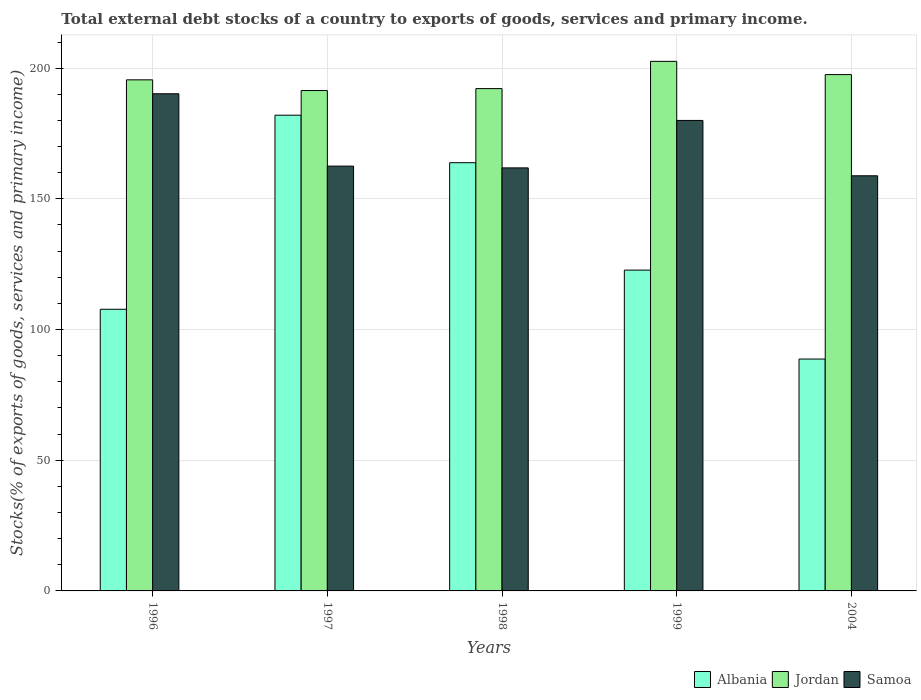How many different coloured bars are there?
Provide a succinct answer. 3. How many groups of bars are there?
Your response must be concise. 5. Are the number of bars per tick equal to the number of legend labels?
Offer a terse response. Yes. How many bars are there on the 4th tick from the right?
Offer a terse response. 3. What is the label of the 5th group of bars from the left?
Offer a terse response. 2004. What is the total debt stocks in Jordan in 2004?
Make the answer very short. 197.54. Across all years, what is the maximum total debt stocks in Jordan?
Make the answer very short. 202.6. Across all years, what is the minimum total debt stocks in Jordan?
Offer a very short reply. 191.43. In which year was the total debt stocks in Albania maximum?
Keep it short and to the point. 1997. What is the total total debt stocks in Albania in the graph?
Provide a short and direct response. 665.02. What is the difference between the total debt stocks in Albania in 1996 and that in 1997?
Give a very brief answer. -74.25. What is the difference between the total debt stocks in Samoa in 1997 and the total debt stocks in Albania in 2004?
Provide a short and direct response. 73.81. What is the average total debt stocks in Samoa per year?
Your answer should be very brief. 170.68. In the year 1996, what is the difference between the total debt stocks in Jordan and total debt stocks in Albania?
Offer a terse response. 87.78. What is the ratio of the total debt stocks in Jordan in 1996 to that in 1997?
Offer a terse response. 1.02. What is the difference between the highest and the second highest total debt stocks in Albania?
Make the answer very short. 18.17. What is the difference between the highest and the lowest total debt stocks in Albania?
Offer a very short reply. 93.29. What does the 3rd bar from the left in 2004 represents?
Your answer should be very brief. Samoa. What does the 3rd bar from the right in 1996 represents?
Ensure brevity in your answer.  Albania. How many bars are there?
Offer a terse response. 15. What is the difference between two consecutive major ticks on the Y-axis?
Your answer should be very brief. 50. Are the values on the major ticks of Y-axis written in scientific E-notation?
Offer a very short reply. No. Does the graph contain any zero values?
Keep it short and to the point. No. Does the graph contain grids?
Your response must be concise. Yes. What is the title of the graph?
Offer a terse response. Total external debt stocks of a country to exports of goods, services and primary income. What is the label or title of the X-axis?
Offer a terse response. Years. What is the label or title of the Y-axis?
Provide a short and direct response. Stocks(% of exports of goods, services and primary income). What is the Stocks(% of exports of goods, services and primary income) in Albania in 1996?
Your answer should be very brief. 107.75. What is the Stocks(% of exports of goods, services and primary income) in Jordan in 1996?
Provide a short and direct response. 195.53. What is the Stocks(% of exports of goods, services and primary income) of Samoa in 1996?
Ensure brevity in your answer.  190.2. What is the Stocks(% of exports of goods, services and primary income) of Albania in 1997?
Your response must be concise. 182. What is the Stocks(% of exports of goods, services and primary income) in Jordan in 1997?
Offer a very short reply. 191.43. What is the Stocks(% of exports of goods, services and primary income) of Samoa in 1997?
Offer a very short reply. 162.53. What is the Stocks(% of exports of goods, services and primary income) of Albania in 1998?
Offer a terse response. 163.83. What is the Stocks(% of exports of goods, services and primary income) in Jordan in 1998?
Provide a succinct answer. 192.18. What is the Stocks(% of exports of goods, services and primary income) of Samoa in 1998?
Your answer should be compact. 161.84. What is the Stocks(% of exports of goods, services and primary income) in Albania in 1999?
Offer a terse response. 122.73. What is the Stocks(% of exports of goods, services and primary income) in Jordan in 1999?
Offer a very short reply. 202.6. What is the Stocks(% of exports of goods, services and primary income) in Samoa in 1999?
Offer a terse response. 180. What is the Stocks(% of exports of goods, services and primary income) of Albania in 2004?
Your response must be concise. 88.71. What is the Stocks(% of exports of goods, services and primary income) in Jordan in 2004?
Offer a very short reply. 197.54. What is the Stocks(% of exports of goods, services and primary income) in Samoa in 2004?
Provide a short and direct response. 158.82. Across all years, what is the maximum Stocks(% of exports of goods, services and primary income) of Albania?
Make the answer very short. 182. Across all years, what is the maximum Stocks(% of exports of goods, services and primary income) in Jordan?
Offer a very short reply. 202.6. Across all years, what is the maximum Stocks(% of exports of goods, services and primary income) in Samoa?
Ensure brevity in your answer.  190.2. Across all years, what is the minimum Stocks(% of exports of goods, services and primary income) in Albania?
Ensure brevity in your answer.  88.71. Across all years, what is the minimum Stocks(% of exports of goods, services and primary income) of Jordan?
Ensure brevity in your answer.  191.43. Across all years, what is the minimum Stocks(% of exports of goods, services and primary income) of Samoa?
Keep it short and to the point. 158.82. What is the total Stocks(% of exports of goods, services and primary income) in Albania in the graph?
Offer a very short reply. 665.02. What is the total Stocks(% of exports of goods, services and primary income) in Jordan in the graph?
Offer a terse response. 979.27. What is the total Stocks(% of exports of goods, services and primary income) in Samoa in the graph?
Provide a short and direct response. 853.38. What is the difference between the Stocks(% of exports of goods, services and primary income) in Albania in 1996 and that in 1997?
Offer a very short reply. -74.25. What is the difference between the Stocks(% of exports of goods, services and primary income) of Jordan in 1996 and that in 1997?
Your response must be concise. 4.1. What is the difference between the Stocks(% of exports of goods, services and primary income) in Samoa in 1996 and that in 1997?
Offer a very short reply. 27.67. What is the difference between the Stocks(% of exports of goods, services and primary income) in Albania in 1996 and that in 1998?
Offer a very short reply. -56.08. What is the difference between the Stocks(% of exports of goods, services and primary income) in Jordan in 1996 and that in 1998?
Offer a terse response. 3.35. What is the difference between the Stocks(% of exports of goods, services and primary income) of Samoa in 1996 and that in 1998?
Provide a succinct answer. 28.36. What is the difference between the Stocks(% of exports of goods, services and primary income) in Albania in 1996 and that in 1999?
Ensure brevity in your answer.  -14.98. What is the difference between the Stocks(% of exports of goods, services and primary income) in Jordan in 1996 and that in 1999?
Provide a succinct answer. -7.07. What is the difference between the Stocks(% of exports of goods, services and primary income) in Samoa in 1996 and that in 1999?
Your response must be concise. 10.2. What is the difference between the Stocks(% of exports of goods, services and primary income) in Albania in 1996 and that in 2004?
Make the answer very short. 19.04. What is the difference between the Stocks(% of exports of goods, services and primary income) of Jordan in 1996 and that in 2004?
Provide a succinct answer. -2.01. What is the difference between the Stocks(% of exports of goods, services and primary income) of Samoa in 1996 and that in 2004?
Keep it short and to the point. 31.38. What is the difference between the Stocks(% of exports of goods, services and primary income) of Albania in 1997 and that in 1998?
Provide a short and direct response. 18.17. What is the difference between the Stocks(% of exports of goods, services and primary income) in Jordan in 1997 and that in 1998?
Provide a short and direct response. -0.74. What is the difference between the Stocks(% of exports of goods, services and primary income) in Samoa in 1997 and that in 1998?
Offer a terse response. 0.68. What is the difference between the Stocks(% of exports of goods, services and primary income) of Albania in 1997 and that in 1999?
Your answer should be compact. 59.27. What is the difference between the Stocks(% of exports of goods, services and primary income) in Jordan in 1997 and that in 1999?
Provide a succinct answer. -11.17. What is the difference between the Stocks(% of exports of goods, services and primary income) in Samoa in 1997 and that in 1999?
Provide a succinct answer. -17.47. What is the difference between the Stocks(% of exports of goods, services and primary income) of Albania in 1997 and that in 2004?
Your response must be concise. 93.29. What is the difference between the Stocks(% of exports of goods, services and primary income) of Jordan in 1997 and that in 2004?
Your answer should be very brief. -6.11. What is the difference between the Stocks(% of exports of goods, services and primary income) of Samoa in 1997 and that in 2004?
Keep it short and to the point. 3.71. What is the difference between the Stocks(% of exports of goods, services and primary income) of Albania in 1998 and that in 1999?
Offer a terse response. 41.09. What is the difference between the Stocks(% of exports of goods, services and primary income) in Jordan in 1998 and that in 1999?
Keep it short and to the point. -10.42. What is the difference between the Stocks(% of exports of goods, services and primary income) in Samoa in 1998 and that in 1999?
Ensure brevity in your answer.  -18.16. What is the difference between the Stocks(% of exports of goods, services and primary income) in Albania in 1998 and that in 2004?
Give a very brief answer. 75.12. What is the difference between the Stocks(% of exports of goods, services and primary income) of Jordan in 1998 and that in 2004?
Offer a terse response. -5.36. What is the difference between the Stocks(% of exports of goods, services and primary income) of Samoa in 1998 and that in 2004?
Keep it short and to the point. 3.02. What is the difference between the Stocks(% of exports of goods, services and primary income) of Albania in 1999 and that in 2004?
Keep it short and to the point. 34.02. What is the difference between the Stocks(% of exports of goods, services and primary income) in Jordan in 1999 and that in 2004?
Give a very brief answer. 5.06. What is the difference between the Stocks(% of exports of goods, services and primary income) in Samoa in 1999 and that in 2004?
Give a very brief answer. 21.18. What is the difference between the Stocks(% of exports of goods, services and primary income) of Albania in 1996 and the Stocks(% of exports of goods, services and primary income) of Jordan in 1997?
Offer a terse response. -83.68. What is the difference between the Stocks(% of exports of goods, services and primary income) in Albania in 1996 and the Stocks(% of exports of goods, services and primary income) in Samoa in 1997?
Make the answer very short. -54.77. What is the difference between the Stocks(% of exports of goods, services and primary income) in Jordan in 1996 and the Stocks(% of exports of goods, services and primary income) in Samoa in 1997?
Ensure brevity in your answer.  33. What is the difference between the Stocks(% of exports of goods, services and primary income) in Albania in 1996 and the Stocks(% of exports of goods, services and primary income) in Jordan in 1998?
Give a very brief answer. -84.42. What is the difference between the Stocks(% of exports of goods, services and primary income) in Albania in 1996 and the Stocks(% of exports of goods, services and primary income) in Samoa in 1998?
Ensure brevity in your answer.  -54.09. What is the difference between the Stocks(% of exports of goods, services and primary income) of Jordan in 1996 and the Stocks(% of exports of goods, services and primary income) of Samoa in 1998?
Make the answer very short. 33.69. What is the difference between the Stocks(% of exports of goods, services and primary income) of Albania in 1996 and the Stocks(% of exports of goods, services and primary income) of Jordan in 1999?
Your answer should be compact. -94.85. What is the difference between the Stocks(% of exports of goods, services and primary income) in Albania in 1996 and the Stocks(% of exports of goods, services and primary income) in Samoa in 1999?
Offer a very short reply. -72.25. What is the difference between the Stocks(% of exports of goods, services and primary income) in Jordan in 1996 and the Stocks(% of exports of goods, services and primary income) in Samoa in 1999?
Give a very brief answer. 15.53. What is the difference between the Stocks(% of exports of goods, services and primary income) of Albania in 1996 and the Stocks(% of exports of goods, services and primary income) of Jordan in 2004?
Keep it short and to the point. -89.79. What is the difference between the Stocks(% of exports of goods, services and primary income) of Albania in 1996 and the Stocks(% of exports of goods, services and primary income) of Samoa in 2004?
Your answer should be compact. -51.07. What is the difference between the Stocks(% of exports of goods, services and primary income) in Jordan in 1996 and the Stocks(% of exports of goods, services and primary income) in Samoa in 2004?
Your response must be concise. 36.71. What is the difference between the Stocks(% of exports of goods, services and primary income) of Albania in 1997 and the Stocks(% of exports of goods, services and primary income) of Jordan in 1998?
Provide a succinct answer. -10.18. What is the difference between the Stocks(% of exports of goods, services and primary income) of Albania in 1997 and the Stocks(% of exports of goods, services and primary income) of Samoa in 1998?
Your response must be concise. 20.16. What is the difference between the Stocks(% of exports of goods, services and primary income) of Jordan in 1997 and the Stocks(% of exports of goods, services and primary income) of Samoa in 1998?
Give a very brief answer. 29.59. What is the difference between the Stocks(% of exports of goods, services and primary income) of Albania in 1997 and the Stocks(% of exports of goods, services and primary income) of Jordan in 1999?
Your answer should be very brief. -20.6. What is the difference between the Stocks(% of exports of goods, services and primary income) in Albania in 1997 and the Stocks(% of exports of goods, services and primary income) in Samoa in 1999?
Give a very brief answer. 2. What is the difference between the Stocks(% of exports of goods, services and primary income) in Jordan in 1997 and the Stocks(% of exports of goods, services and primary income) in Samoa in 1999?
Your answer should be compact. 11.43. What is the difference between the Stocks(% of exports of goods, services and primary income) of Albania in 1997 and the Stocks(% of exports of goods, services and primary income) of Jordan in 2004?
Offer a very short reply. -15.54. What is the difference between the Stocks(% of exports of goods, services and primary income) in Albania in 1997 and the Stocks(% of exports of goods, services and primary income) in Samoa in 2004?
Provide a succinct answer. 23.18. What is the difference between the Stocks(% of exports of goods, services and primary income) of Jordan in 1997 and the Stocks(% of exports of goods, services and primary income) of Samoa in 2004?
Keep it short and to the point. 32.61. What is the difference between the Stocks(% of exports of goods, services and primary income) of Albania in 1998 and the Stocks(% of exports of goods, services and primary income) of Jordan in 1999?
Your answer should be very brief. -38.77. What is the difference between the Stocks(% of exports of goods, services and primary income) of Albania in 1998 and the Stocks(% of exports of goods, services and primary income) of Samoa in 1999?
Your response must be concise. -16.17. What is the difference between the Stocks(% of exports of goods, services and primary income) of Jordan in 1998 and the Stocks(% of exports of goods, services and primary income) of Samoa in 1999?
Make the answer very short. 12.18. What is the difference between the Stocks(% of exports of goods, services and primary income) in Albania in 1998 and the Stocks(% of exports of goods, services and primary income) in Jordan in 2004?
Your answer should be very brief. -33.71. What is the difference between the Stocks(% of exports of goods, services and primary income) in Albania in 1998 and the Stocks(% of exports of goods, services and primary income) in Samoa in 2004?
Provide a short and direct response. 5.01. What is the difference between the Stocks(% of exports of goods, services and primary income) in Jordan in 1998 and the Stocks(% of exports of goods, services and primary income) in Samoa in 2004?
Offer a very short reply. 33.36. What is the difference between the Stocks(% of exports of goods, services and primary income) in Albania in 1999 and the Stocks(% of exports of goods, services and primary income) in Jordan in 2004?
Keep it short and to the point. -74.81. What is the difference between the Stocks(% of exports of goods, services and primary income) of Albania in 1999 and the Stocks(% of exports of goods, services and primary income) of Samoa in 2004?
Make the answer very short. -36.09. What is the difference between the Stocks(% of exports of goods, services and primary income) in Jordan in 1999 and the Stocks(% of exports of goods, services and primary income) in Samoa in 2004?
Your answer should be very brief. 43.78. What is the average Stocks(% of exports of goods, services and primary income) in Albania per year?
Your answer should be compact. 133. What is the average Stocks(% of exports of goods, services and primary income) of Jordan per year?
Your answer should be very brief. 195.85. What is the average Stocks(% of exports of goods, services and primary income) in Samoa per year?
Offer a terse response. 170.68. In the year 1996, what is the difference between the Stocks(% of exports of goods, services and primary income) of Albania and Stocks(% of exports of goods, services and primary income) of Jordan?
Provide a succinct answer. -87.78. In the year 1996, what is the difference between the Stocks(% of exports of goods, services and primary income) in Albania and Stocks(% of exports of goods, services and primary income) in Samoa?
Your response must be concise. -82.45. In the year 1996, what is the difference between the Stocks(% of exports of goods, services and primary income) of Jordan and Stocks(% of exports of goods, services and primary income) of Samoa?
Your answer should be very brief. 5.33. In the year 1997, what is the difference between the Stocks(% of exports of goods, services and primary income) in Albania and Stocks(% of exports of goods, services and primary income) in Jordan?
Ensure brevity in your answer.  -9.43. In the year 1997, what is the difference between the Stocks(% of exports of goods, services and primary income) of Albania and Stocks(% of exports of goods, services and primary income) of Samoa?
Offer a terse response. 19.47. In the year 1997, what is the difference between the Stocks(% of exports of goods, services and primary income) in Jordan and Stocks(% of exports of goods, services and primary income) in Samoa?
Your response must be concise. 28.91. In the year 1998, what is the difference between the Stocks(% of exports of goods, services and primary income) in Albania and Stocks(% of exports of goods, services and primary income) in Jordan?
Your answer should be compact. -28.35. In the year 1998, what is the difference between the Stocks(% of exports of goods, services and primary income) in Albania and Stocks(% of exports of goods, services and primary income) in Samoa?
Your answer should be very brief. 1.99. In the year 1998, what is the difference between the Stocks(% of exports of goods, services and primary income) in Jordan and Stocks(% of exports of goods, services and primary income) in Samoa?
Your answer should be compact. 30.34. In the year 1999, what is the difference between the Stocks(% of exports of goods, services and primary income) in Albania and Stocks(% of exports of goods, services and primary income) in Jordan?
Ensure brevity in your answer.  -79.87. In the year 1999, what is the difference between the Stocks(% of exports of goods, services and primary income) in Albania and Stocks(% of exports of goods, services and primary income) in Samoa?
Keep it short and to the point. -57.27. In the year 1999, what is the difference between the Stocks(% of exports of goods, services and primary income) of Jordan and Stocks(% of exports of goods, services and primary income) of Samoa?
Offer a terse response. 22.6. In the year 2004, what is the difference between the Stocks(% of exports of goods, services and primary income) in Albania and Stocks(% of exports of goods, services and primary income) in Jordan?
Give a very brief answer. -108.83. In the year 2004, what is the difference between the Stocks(% of exports of goods, services and primary income) of Albania and Stocks(% of exports of goods, services and primary income) of Samoa?
Keep it short and to the point. -70.11. In the year 2004, what is the difference between the Stocks(% of exports of goods, services and primary income) of Jordan and Stocks(% of exports of goods, services and primary income) of Samoa?
Your answer should be compact. 38.72. What is the ratio of the Stocks(% of exports of goods, services and primary income) in Albania in 1996 to that in 1997?
Provide a short and direct response. 0.59. What is the ratio of the Stocks(% of exports of goods, services and primary income) of Jordan in 1996 to that in 1997?
Provide a short and direct response. 1.02. What is the ratio of the Stocks(% of exports of goods, services and primary income) in Samoa in 1996 to that in 1997?
Provide a succinct answer. 1.17. What is the ratio of the Stocks(% of exports of goods, services and primary income) of Albania in 1996 to that in 1998?
Offer a terse response. 0.66. What is the ratio of the Stocks(% of exports of goods, services and primary income) in Jordan in 1996 to that in 1998?
Your answer should be very brief. 1.02. What is the ratio of the Stocks(% of exports of goods, services and primary income) of Samoa in 1996 to that in 1998?
Keep it short and to the point. 1.18. What is the ratio of the Stocks(% of exports of goods, services and primary income) in Albania in 1996 to that in 1999?
Make the answer very short. 0.88. What is the ratio of the Stocks(% of exports of goods, services and primary income) of Jordan in 1996 to that in 1999?
Your response must be concise. 0.97. What is the ratio of the Stocks(% of exports of goods, services and primary income) of Samoa in 1996 to that in 1999?
Your answer should be very brief. 1.06. What is the ratio of the Stocks(% of exports of goods, services and primary income) in Albania in 1996 to that in 2004?
Provide a short and direct response. 1.21. What is the ratio of the Stocks(% of exports of goods, services and primary income) of Samoa in 1996 to that in 2004?
Offer a very short reply. 1.2. What is the ratio of the Stocks(% of exports of goods, services and primary income) of Albania in 1997 to that in 1998?
Keep it short and to the point. 1.11. What is the ratio of the Stocks(% of exports of goods, services and primary income) of Jordan in 1997 to that in 1998?
Keep it short and to the point. 1. What is the ratio of the Stocks(% of exports of goods, services and primary income) in Albania in 1997 to that in 1999?
Provide a succinct answer. 1.48. What is the ratio of the Stocks(% of exports of goods, services and primary income) in Jordan in 1997 to that in 1999?
Your response must be concise. 0.94. What is the ratio of the Stocks(% of exports of goods, services and primary income) of Samoa in 1997 to that in 1999?
Keep it short and to the point. 0.9. What is the ratio of the Stocks(% of exports of goods, services and primary income) in Albania in 1997 to that in 2004?
Offer a very short reply. 2.05. What is the ratio of the Stocks(% of exports of goods, services and primary income) in Jordan in 1997 to that in 2004?
Provide a succinct answer. 0.97. What is the ratio of the Stocks(% of exports of goods, services and primary income) of Samoa in 1997 to that in 2004?
Give a very brief answer. 1.02. What is the ratio of the Stocks(% of exports of goods, services and primary income) in Albania in 1998 to that in 1999?
Keep it short and to the point. 1.33. What is the ratio of the Stocks(% of exports of goods, services and primary income) of Jordan in 1998 to that in 1999?
Your answer should be very brief. 0.95. What is the ratio of the Stocks(% of exports of goods, services and primary income) in Samoa in 1998 to that in 1999?
Give a very brief answer. 0.9. What is the ratio of the Stocks(% of exports of goods, services and primary income) of Albania in 1998 to that in 2004?
Keep it short and to the point. 1.85. What is the ratio of the Stocks(% of exports of goods, services and primary income) of Jordan in 1998 to that in 2004?
Provide a succinct answer. 0.97. What is the ratio of the Stocks(% of exports of goods, services and primary income) of Samoa in 1998 to that in 2004?
Your response must be concise. 1.02. What is the ratio of the Stocks(% of exports of goods, services and primary income) of Albania in 1999 to that in 2004?
Keep it short and to the point. 1.38. What is the ratio of the Stocks(% of exports of goods, services and primary income) of Jordan in 1999 to that in 2004?
Your response must be concise. 1.03. What is the ratio of the Stocks(% of exports of goods, services and primary income) of Samoa in 1999 to that in 2004?
Offer a very short reply. 1.13. What is the difference between the highest and the second highest Stocks(% of exports of goods, services and primary income) of Albania?
Offer a terse response. 18.17. What is the difference between the highest and the second highest Stocks(% of exports of goods, services and primary income) in Jordan?
Your answer should be compact. 5.06. What is the difference between the highest and the second highest Stocks(% of exports of goods, services and primary income) of Samoa?
Your response must be concise. 10.2. What is the difference between the highest and the lowest Stocks(% of exports of goods, services and primary income) in Albania?
Your response must be concise. 93.29. What is the difference between the highest and the lowest Stocks(% of exports of goods, services and primary income) of Jordan?
Make the answer very short. 11.17. What is the difference between the highest and the lowest Stocks(% of exports of goods, services and primary income) in Samoa?
Give a very brief answer. 31.38. 